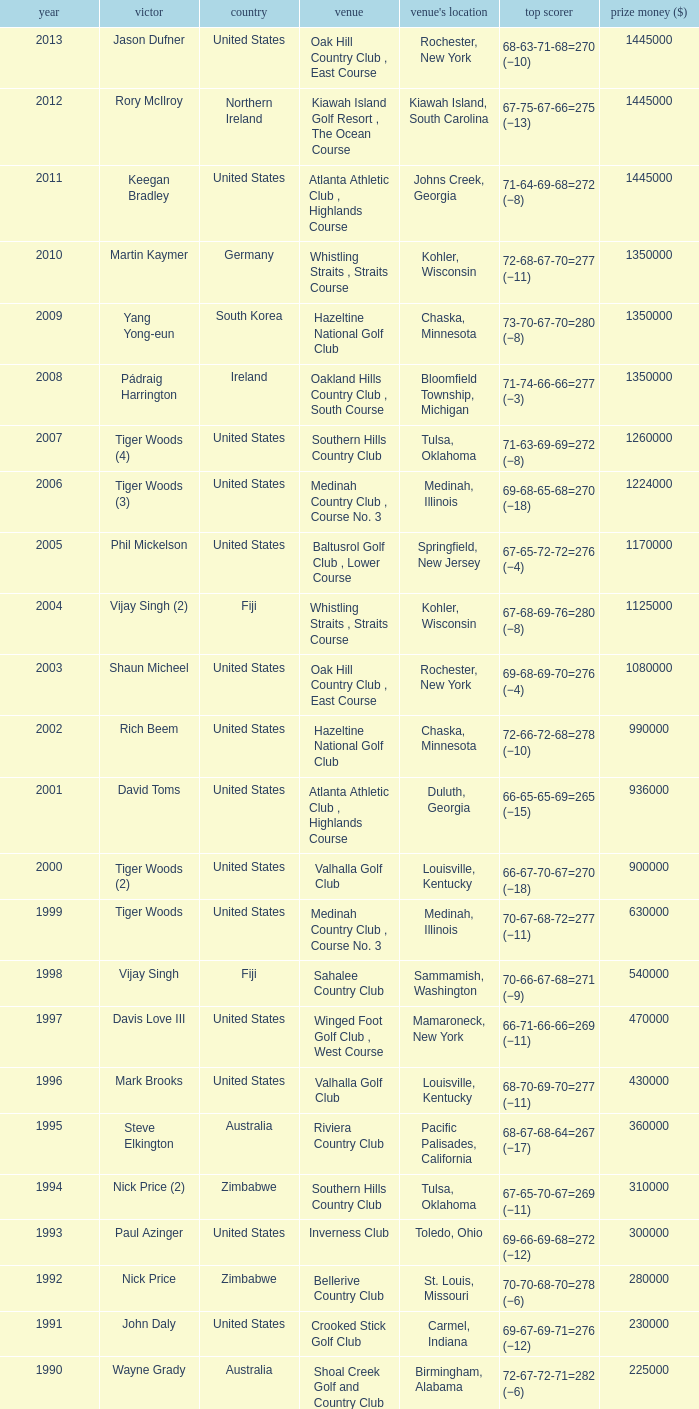List all winning scores from 1982. 63-69-68-72=272 (−8). 